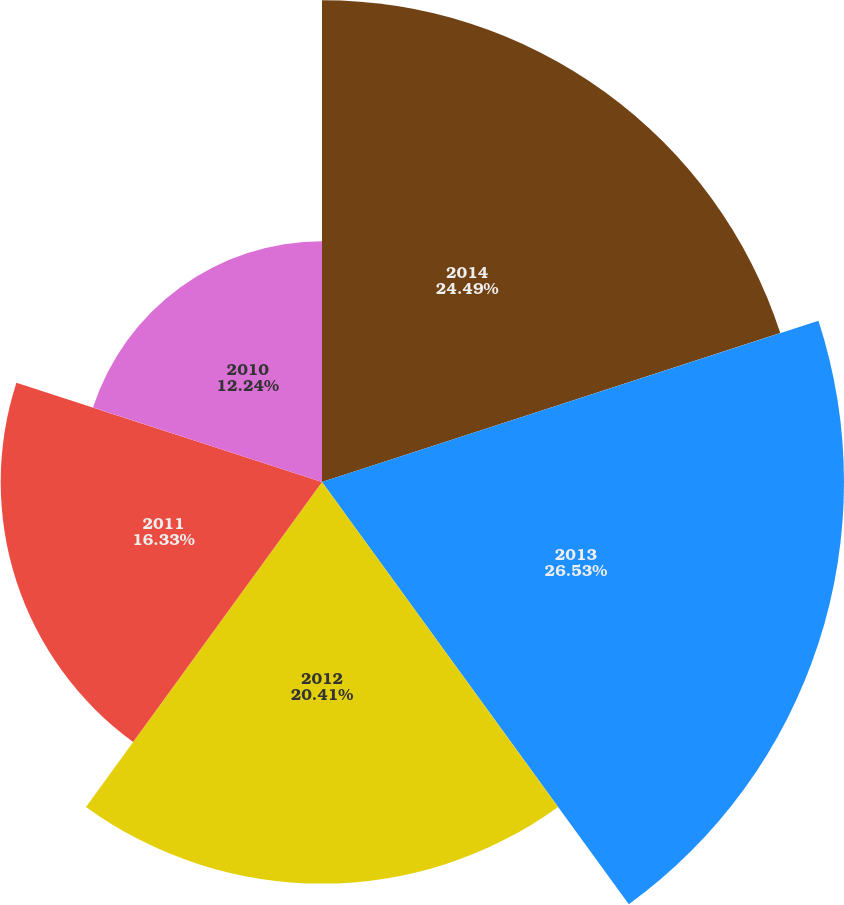Convert chart to OTSL. <chart><loc_0><loc_0><loc_500><loc_500><pie_chart><fcel>2014<fcel>2013<fcel>2012<fcel>2011<fcel>2010<nl><fcel>24.49%<fcel>26.53%<fcel>20.41%<fcel>16.33%<fcel>12.24%<nl></chart> 